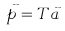Convert formula to latex. <formula><loc_0><loc_0><loc_500><loc_500>\vec { p } = T \vec { a }</formula> 